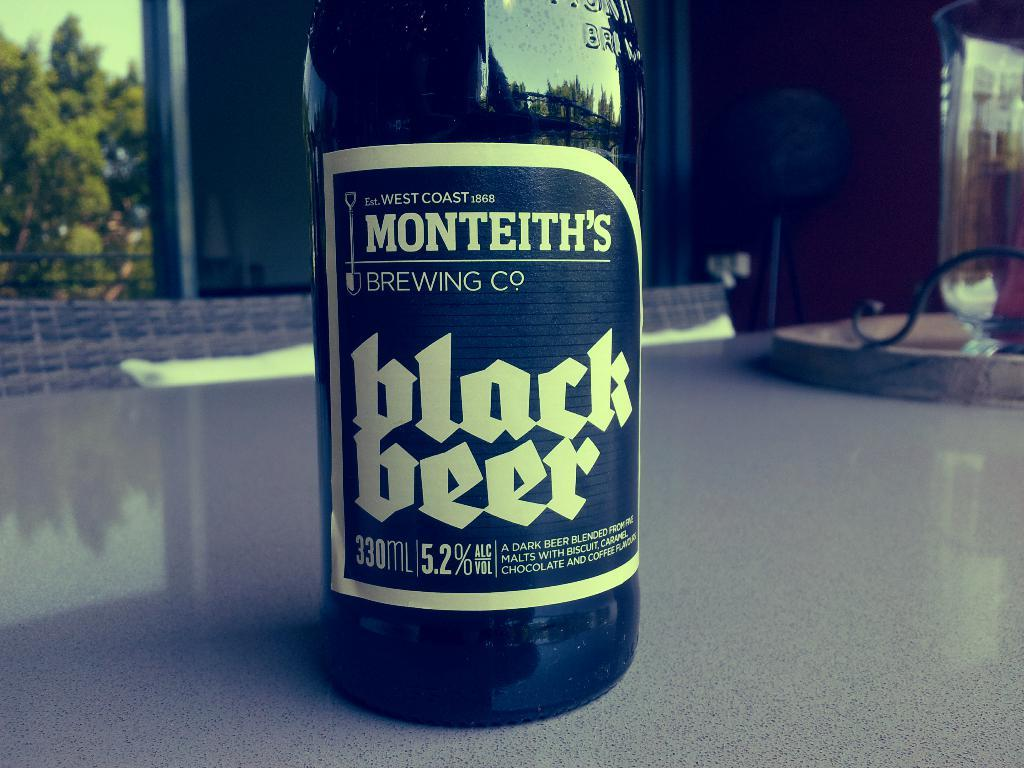<image>
Write a terse but informative summary of the picture. a close up of a bottle of Menteith's Black Beer 330 ML 